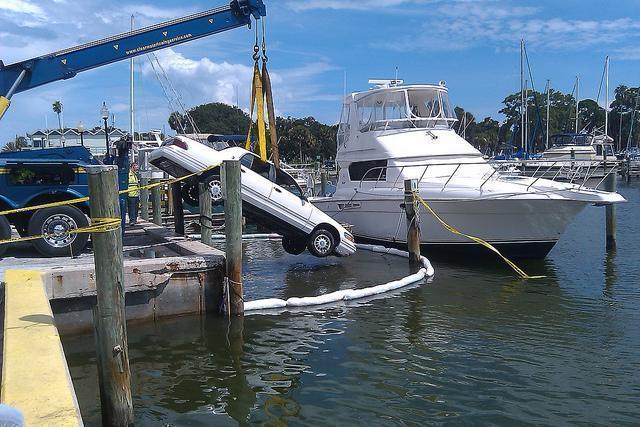Where has the white car on the yellow straps been?
Make your selection and explain in format: 'Answer: answer
Rationale: rationale.'
Options: Harbor water, towtruck bed, boat, dock. Answer: harbor water.
Rationale: It was in the water and being pulled out. 